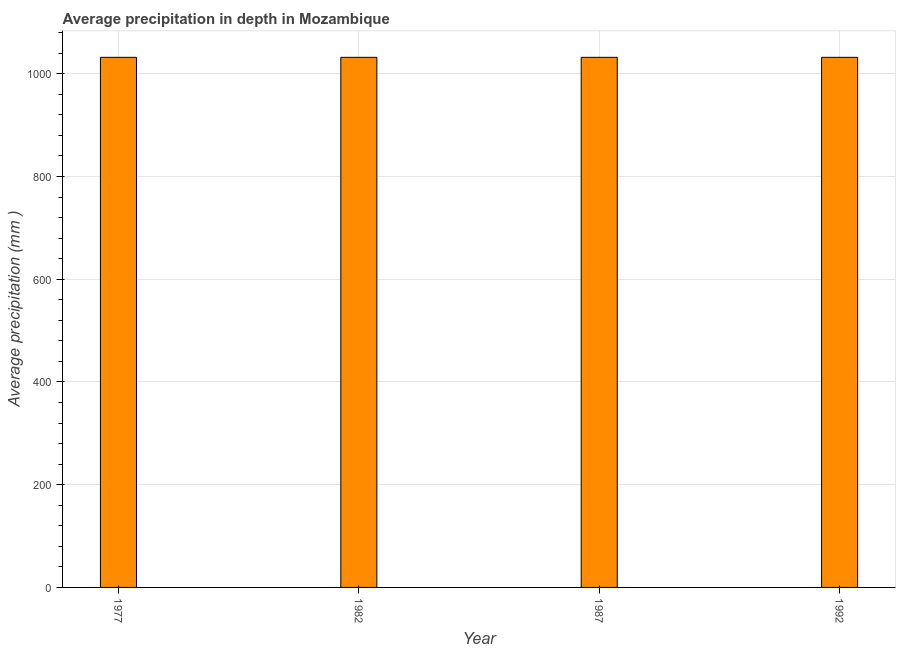Does the graph contain any zero values?
Your answer should be very brief. No. What is the title of the graph?
Your answer should be very brief. Average precipitation in depth in Mozambique. What is the label or title of the X-axis?
Provide a succinct answer. Year. What is the label or title of the Y-axis?
Offer a very short reply. Average precipitation (mm ). What is the average precipitation in depth in 1987?
Keep it short and to the point. 1032. Across all years, what is the maximum average precipitation in depth?
Make the answer very short. 1032. Across all years, what is the minimum average precipitation in depth?
Give a very brief answer. 1032. In which year was the average precipitation in depth maximum?
Offer a very short reply. 1977. What is the sum of the average precipitation in depth?
Keep it short and to the point. 4128. What is the difference between the average precipitation in depth in 1982 and 1992?
Your answer should be compact. 0. What is the average average precipitation in depth per year?
Your response must be concise. 1032. What is the median average precipitation in depth?
Offer a very short reply. 1032. In how many years, is the average precipitation in depth greater than 280 mm?
Ensure brevity in your answer.  4. What is the ratio of the average precipitation in depth in 1977 to that in 1992?
Keep it short and to the point. 1. What is the difference between the highest and the second highest average precipitation in depth?
Make the answer very short. 0. What is the difference between the highest and the lowest average precipitation in depth?
Make the answer very short. 0. In how many years, is the average precipitation in depth greater than the average average precipitation in depth taken over all years?
Your response must be concise. 0. How many bars are there?
Make the answer very short. 4. Are all the bars in the graph horizontal?
Provide a succinct answer. No. What is the difference between two consecutive major ticks on the Y-axis?
Keep it short and to the point. 200. Are the values on the major ticks of Y-axis written in scientific E-notation?
Give a very brief answer. No. What is the Average precipitation (mm ) in 1977?
Your response must be concise. 1032. What is the Average precipitation (mm ) in 1982?
Keep it short and to the point. 1032. What is the Average precipitation (mm ) of 1987?
Offer a terse response. 1032. What is the Average precipitation (mm ) in 1992?
Provide a short and direct response. 1032. What is the difference between the Average precipitation (mm ) in 1977 and 1982?
Make the answer very short. 0. What is the difference between the Average precipitation (mm ) in 1977 and 1987?
Offer a very short reply. 0. What is the difference between the Average precipitation (mm ) in 1977 and 1992?
Provide a succinct answer. 0. What is the difference between the Average precipitation (mm ) in 1982 and 1987?
Provide a succinct answer. 0. What is the difference between the Average precipitation (mm ) in 1982 and 1992?
Your answer should be compact. 0. What is the ratio of the Average precipitation (mm ) in 1977 to that in 1982?
Provide a succinct answer. 1. What is the ratio of the Average precipitation (mm ) in 1977 to that in 1987?
Offer a terse response. 1. What is the ratio of the Average precipitation (mm ) in 1977 to that in 1992?
Offer a very short reply. 1. What is the ratio of the Average precipitation (mm ) in 1982 to that in 1987?
Provide a succinct answer. 1. What is the ratio of the Average precipitation (mm ) in 1982 to that in 1992?
Provide a short and direct response. 1. What is the ratio of the Average precipitation (mm ) in 1987 to that in 1992?
Provide a succinct answer. 1. 